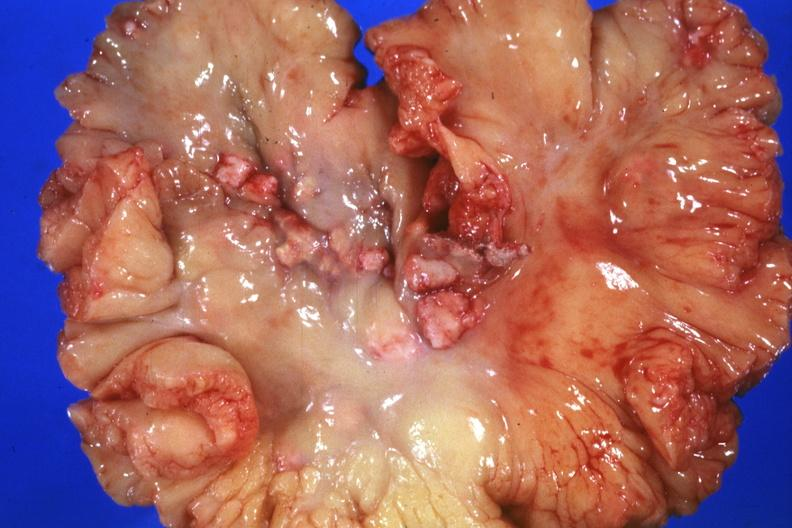does retroperitoneum show mesentery with involved nodes?
Answer the question using a single word or phrase. No 